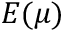<formula> <loc_0><loc_0><loc_500><loc_500>\ m a t h p a l e t t e { E } ( \mu )</formula> 